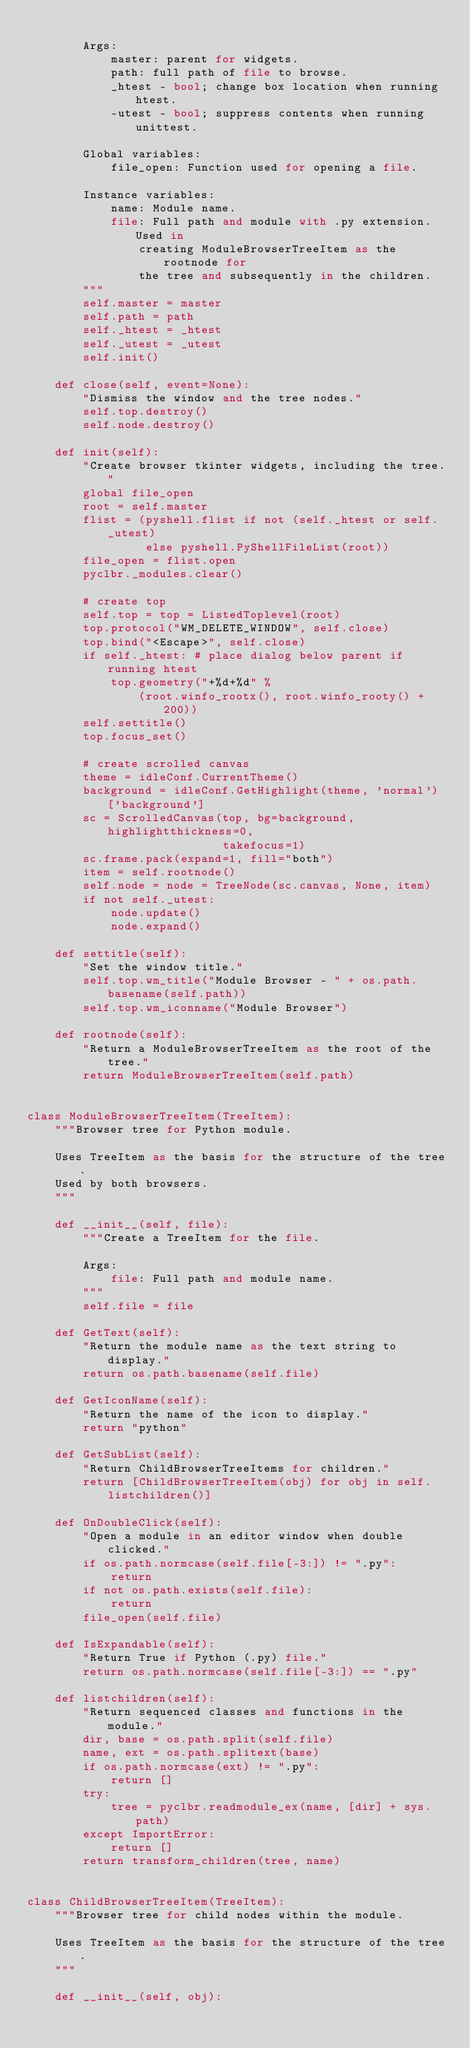Convert code to text. <code><loc_0><loc_0><loc_500><loc_500><_Python_>
        Args:
            master: parent for widgets.
            path: full path of file to browse.
            _htest - bool; change box location when running htest.
            -utest - bool; suppress contents when running unittest.

        Global variables:
            file_open: Function used for opening a file.

        Instance variables:
            name: Module name.
            file: Full path and module with .py extension.  Used in
                creating ModuleBrowserTreeItem as the rootnode for
                the tree and subsequently in the children.
        """
        self.master = master
        self.path = path
        self._htest = _htest
        self._utest = _utest
        self.init()

    def close(self, event=None):
        "Dismiss the window and the tree nodes."
        self.top.destroy()
        self.node.destroy()

    def init(self):
        "Create browser tkinter widgets, including the tree."
        global file_open
        root = self.master
        flist = (pyshell.flist if not (self._htest or self._utest)
                 else pyshell.PyShellFileList(root))
        file_open = flist.open
        pyclbr._modules.clear()

        # create top
        self.top = top = ListedToplevel(root)
        top.protocol("WM_DELETE_WINDOW", self.close)
        top.bind("<Escape>", self.close)
        if self._htest: # place dialog below parent if running htest
            top.geometry("+%d+%d" %
                (root.winfo_rootx(), root.winfo_rooty() + 200))
        self.settitle()
        top.focus_set()

        # create scrolled canvas
        theme = idleConf.CurrentTheme()
        background = idleConf.GetHighlight(theme, 'normal')['background']
        sc = ScrolledCanvas(top, bg=background, highlightthickness=0,
                            takefocus=1)
        sc.frame.pack(expand=1, fill="both")
        item = self.rootnode()
        self.node = node = TreeNode(sc.canvas, None, item)
        if not self._utest:
            node.update()
            node.expand()

    def settitle(self):
        "Set the window title."
        self.top.wm_title("Module Browser - " + os.path.basename(self.path))
        self.top.wm_iconname("Module Browser")

    def rootnode(self):
        "Return a ModuleBrowserTreeItem as the root of the tree."
        return ModuleBrowserTreeItem(self.path)


class ModuleBrowserTreeItem(TreeItem):
    """Browser tree for Python module.

    Uses TreeItem as the basis for the structure of the tree.
    Used by both browsers.
    """

    def __init__(self, file):
        """Create a TreeItem for the file.

        Args:
            file: Full path and module name.
        """
        self.file = file

    def GetText(self):
        "Return the module name as the text string to display."
        return os.path.basename(self.file)

    def GetIconName(self):
        "Return the name of the icon to display."
        return "python"

    def GetSubList(self):
        "Return ChildBrowserTreeItems for children."
        return [ChildBrowserTreeItem(obj) for obj in self.listchildren()]

    def OnDoubleClick(self):
        "Open a module in an editor window when double clicked."
        if os.path.normcase(self.file[-3:]) != ".py":
            return
        if not os.path.exists(self.file):
            return
        file_open(self.file)

    def IsExpandable(self):
        "Return True if Python (.py) file."
        return os.path.normcase(self.file[-3:]) == ".py"

    def listchildren(self):
        "Return sequenced classes and functions in the module."
        dir, base = os.path.split(self.file)
        name, ext = os.path.splitext(base)
        if os.path.normcase(ext) != ".py":
            return []
        try:
            tree = pyclbr.readmodule_ex(name, [dir] + sys.path)
        except ImportError:
            return []
        return transform_children(tree, name)


class ChildBrowserTreeItem(TreeItem):
    """Browser tree for child nodes within the module.

    Uses TreeItem as the basis for the structure of the tree.
    """

    def __init__(self, obj):</code> 